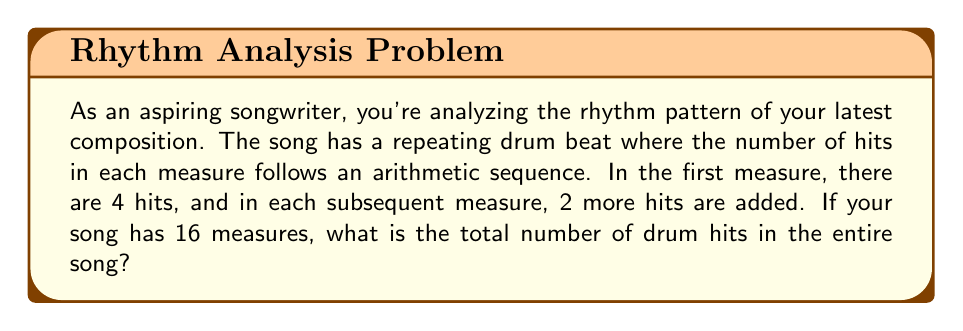Help me with this question. Let's approach this step-by-step using arithmetic sequences and series:

1) First, identify the sequence:
   - First term (a₁) = 4
   - Common difference (d) = 2
   - Number of terms (n) = 16 (as there are 16 measures)

2) The arithmetic sequence is: 4, 6, 8, 10, ...

3) To find the last term (a₁₆):
   $$a_n = a_1 + (n-1)d$$
   $$a_{16} = 4 + (16-1)2 = 4 + 30 = 34$$

4) Now that we have the first term (a₁) and the last term (a₁₆), we can use the formula for the sum of an arithmetic series:
   $$S_n = \frac{n}{2}(a_1 + a_n)$$

   Where:
   $S_n$ is the sum of the series
   $n$ is the number of terms
   $a_1$ is the first term
   $a_n$ is the last term

5) Substituting our values:
   $$S_{16} = \frac{16}{2}(4 + 34)$$
   $$S_{16} = 8(38)$$
   $$S_{16} = 304$$

Therefore, the total number of drum hits in the entire song is 304.
Answer: 304 drum hits 